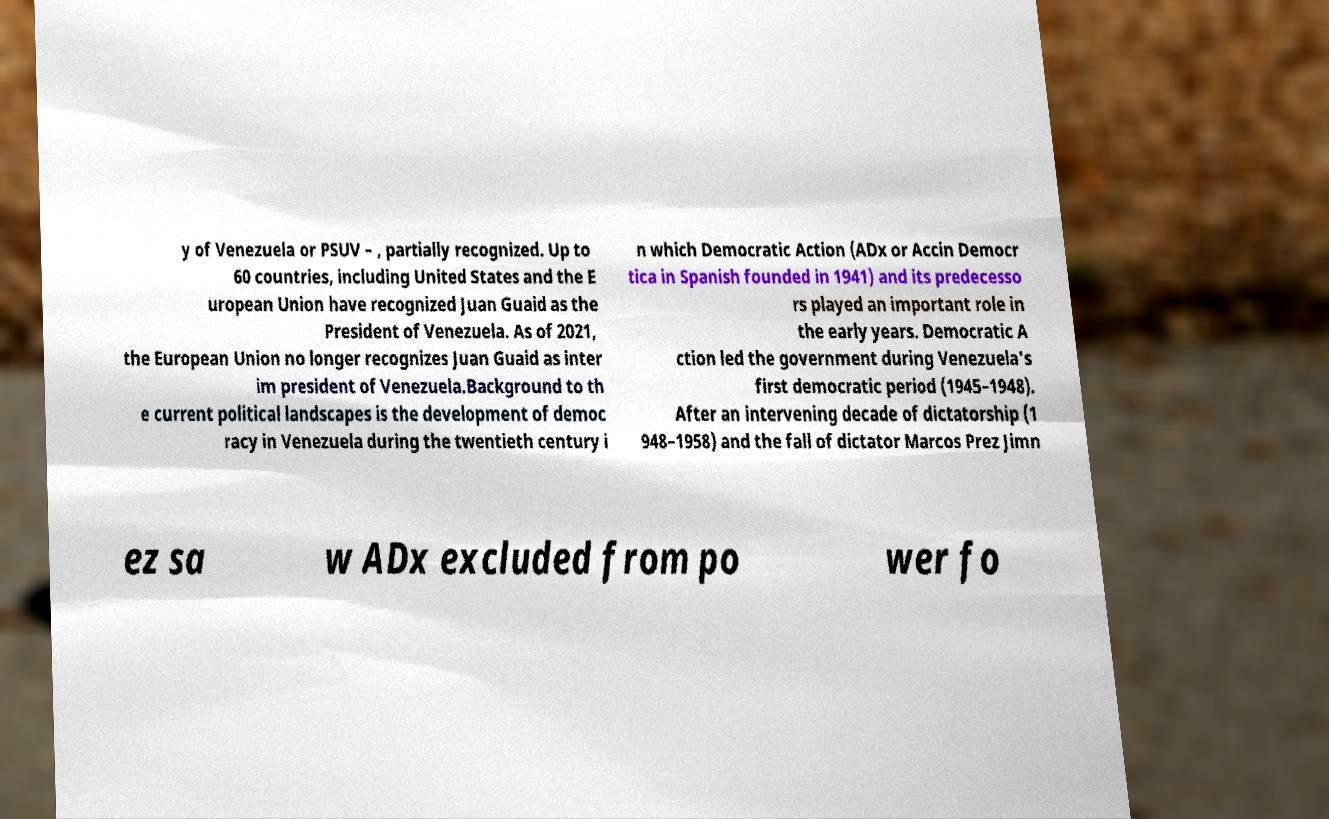For documentation purposes, I need the text within this image transcribed. Could you provide that? y of Venezuela or PSUV – , partially recognized. Up to 60 countries, including United States and the E uropean Union have recognized Juan Guaid as the President of Venezuela. As of 2021, the European Union no longer recognizes Juan Guaid as inter im president of Venezuela.Background to th e current political landscapes is the development of democ racy in Venezuela during the twentieth century i n which Democratic Action (ADx or Accin Democr tica in Spanish founded in 1941) and its predecesso rs played an important role in the early years. Democratic A ction led the government during Venezuela's first democratic period (1945–1948). After an intervening decade of dictatorship (1 948–1958) and the fall of dictator Marcos Prez Jimn ez sa w ADx excluded from po wer fo 